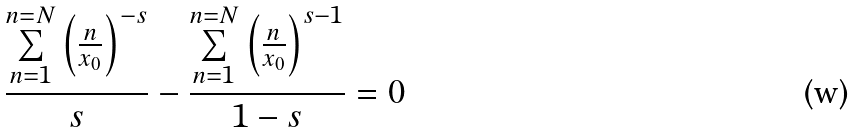Convert formula to latex. <formula><loc_0><loc_0><loc_500><loc_500>\frac { \underset { n = 1 } { \overset { n = N } { \sum } } \left ( \frac { n } { x _ { 0 } } \right ) ^ { - s } } { s } - \frac { \underset { n = 1 } { \overset { n = N } { \sum } } \left ( \frac { n } { x _ { 0 } } \right ) ^ { s - 1 } } { 1 - s } = 0</formula> 